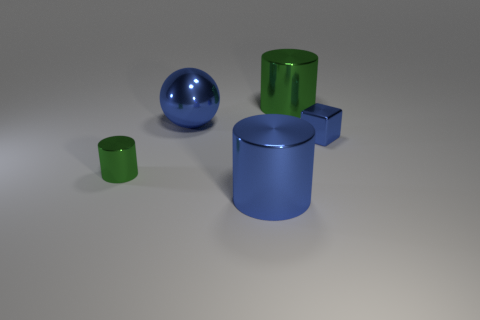There is a big cylinder that is left of the green metal cylinder right of the small green shiny cylinder; are there any big green cylinders that are left of it?
Your answer should be very brief. No. Is the number of blue cubes greater than the number of matte balls?
Provide a succinct answer. Yes. There is a tiny shiny object left of the blue metallic cube; what is its color?
Make the answer very short. Green. Are there more large things in front of the blue cube than large green metallic objects?
Give a very brief answer. No. What number of other objects are there of the same shape as the tiny blue object?
Ensure brevity in your answer.  0. What color is the cylinder that is on the right side of the large metal cylinder in front of the tiny metallic object behind the small green metallic thing?
Your answer should be very brief. Green. There is a green object that is behind the small metal cube; is it the same shape as the tiny green thing?
Your answer should be compact. Yes. What number of tiny shiny things are there?
Provide a succinct answer. 2. What number of yellow rubber spheres have the same size as the blue shiny cylinder?
Your answer should be very brief. 0. What is the big blue cylinder made of?
Provide a short and direct response. Metal. 